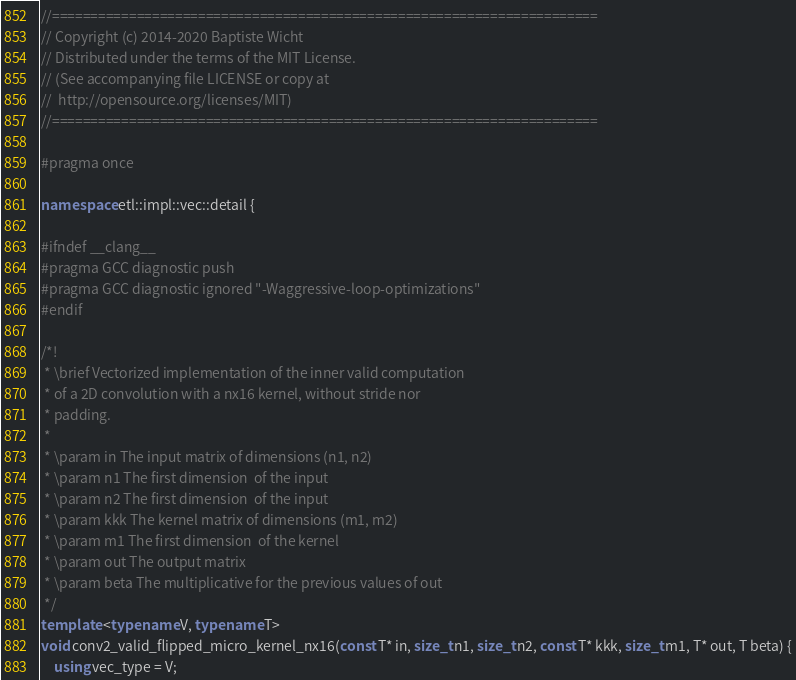<code> <loc_0><loc_0><loc_500><loc_500><_C++_>//=======================================================================
// Copyright (c) 2014-2020 Baptiste Wicht
// Distributed under the terms of the MIT License.
// (See accompanying file LICENSE or copy at
//  http://opensource.org/licenses/MIT)
//=======================================================================

#pragma once

namespace etl::impl::vec::detail {

#ifndef __clang__
#pragma GCC diagnostic push
#pragma GCC diagnostic ignored "-Waggressive-loop-optimizations"
#endif

/*!
 * \brief Vectorized implementation of the inner valid computation
 * of a 2D convolution with a nx16 kernel, without stride nor
 * padding.
 *
 * \param in The input matrix of dimensions (n1, n2)
 * \param n1 The first dimension  of the input
 * \param n2 The first dimension  of the input
 * \param kkk The kernel matrix of dimensions (m1, m2)
 * \param m1 The first dimension  of the kernel
 * \param out The output matrix
 * \param beta The multiplicative for the previous values of out
 */
template <typename V, typename T>
void conv2_valid_flipped_micro_kernel_nx16(const T* in, size_t n1, size_t n2, const T* kkk, size_t m1, T* out, T beta) {
    using vec_type = V;
</code> 